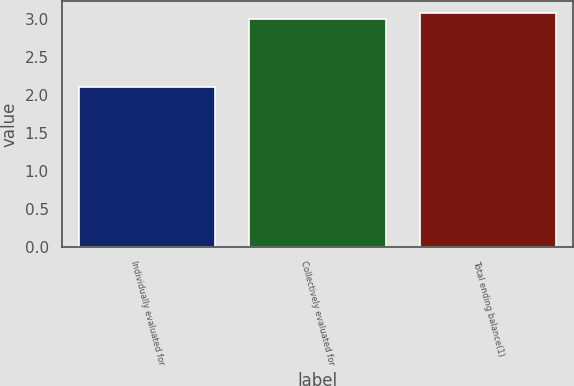<chart> <loc_0><loc_0><loc_500><loc_500><bar_chart><fcel>Individually evaluated for<fcel>Collectively evaluated for<fcel>Total ending balance(1)<nl><fcel>2.11<fcel>3<fcel>3.09<nl></chart> 